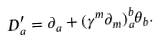Convert formula to latex. <formula><loc_0><loc_0><loc_500><loc_500>D _ { a } ^ { \prime } = \partial _ { a } + ( \gamma ^ { m } \partial _ { m } ) ^ { b } _ { a } \theta _ { b } .</formula> 